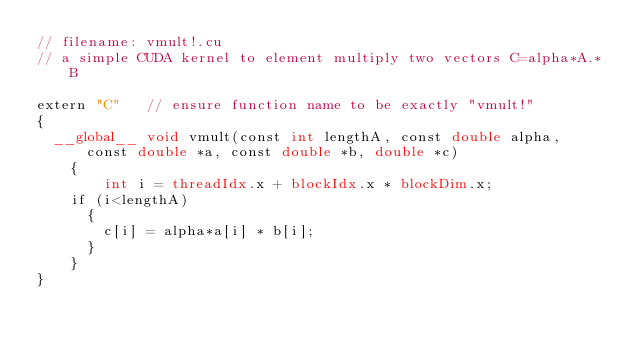Convert code to text. <code><loc_0><loc_0><loc_500><loc_500><_Cuda_>// filename: vmult!.cu
// a simple CUDA kernel to element multiply two vectors C=alpha*A.*B

extern "C"   // ensure function name to be exactly "vmult!"
{
  __global__ void vmult(const int lengthA, const double alpha, const double *a, const double *b, double *c)
    {
        int i = threadIdx.x + blockIdx.x * blockDim.x;
	if (i<lengthA)
	  {
	    c[i] = alpha*a[i] * b[i];
	  }
    }
}</code> 